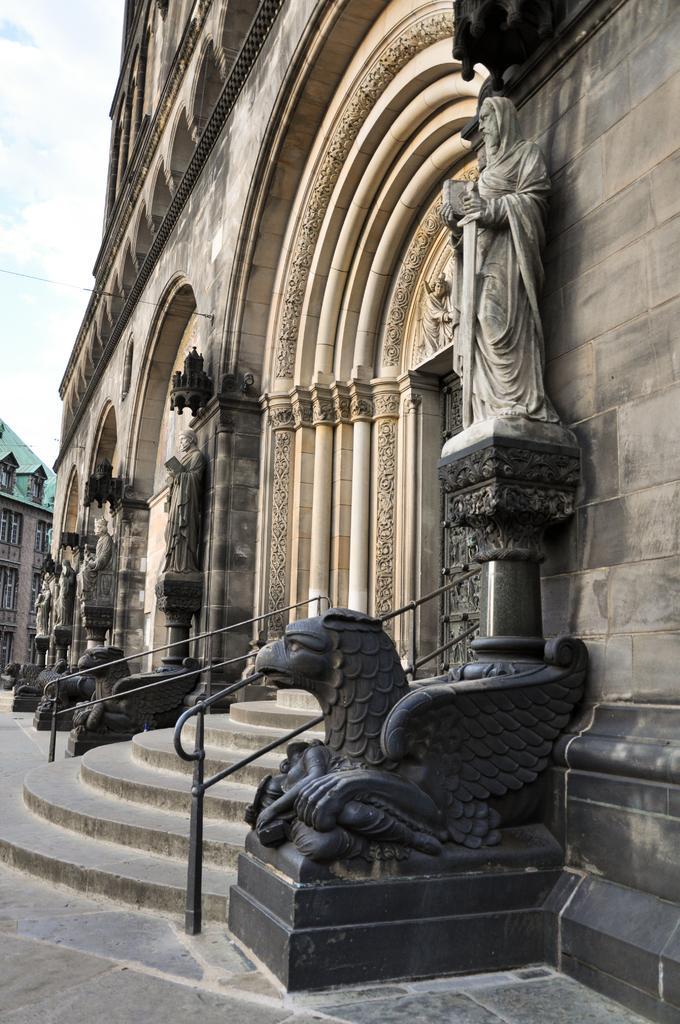In one or two sentences, can you explain what this image depicts? In this image there are buildings and we can see sculptures carved on the building. There are stairs and we can see railings. In the background there is sky. 